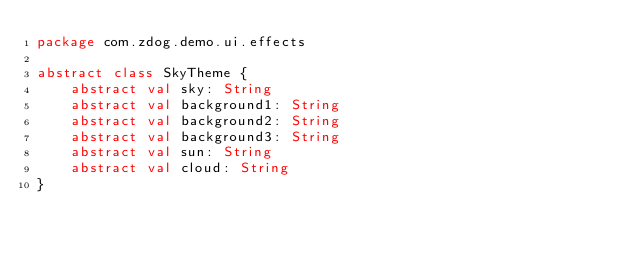Convert code to text. <code><loc_0><loc_0><loc_500><loc_500><_Kotlin_>package com.zdog.demo.ui.effects

abstract class SkyTheme {
    abstract val sky: String
    abstract val background1: String
    abstract val background2: String
    abstract val background3: String
    abstract val sun: String
    abstract val cloud: String
}</code> 